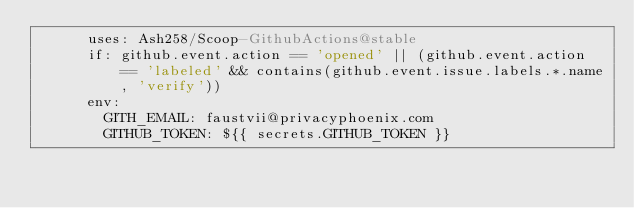Convert code to text. <code><loc_0><loc_0><loc_500><loc_500><_YAML_>      uses: Ash258/Scoop-GithubActions@stable
      if: github.event.action == 'opened' || (github.event.action == 'labeled' && contains(github.event.issue.labels.*.name, 'verify'))
      env:
        GITH_EMAIL: faustvii@privacyphoenix.com
        GITHUB_TOKEN: ${{ secrets.GITHUB_TOKEN }}
</code> 